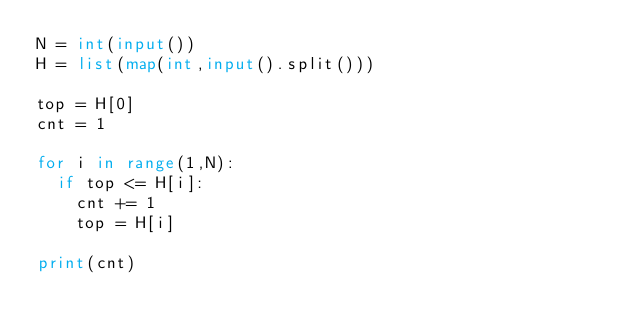Convert code to text. <code><loc_0><loc_0><loc_500><loc_500><_Python_>N = int(input())
H = list(map(int,input().split()))

top = H[0]
cnt = 1

for i in range(1,N):
  if top <= H[i]:
    cnt += 1
    top = H[i]

print(cnt)</code> 